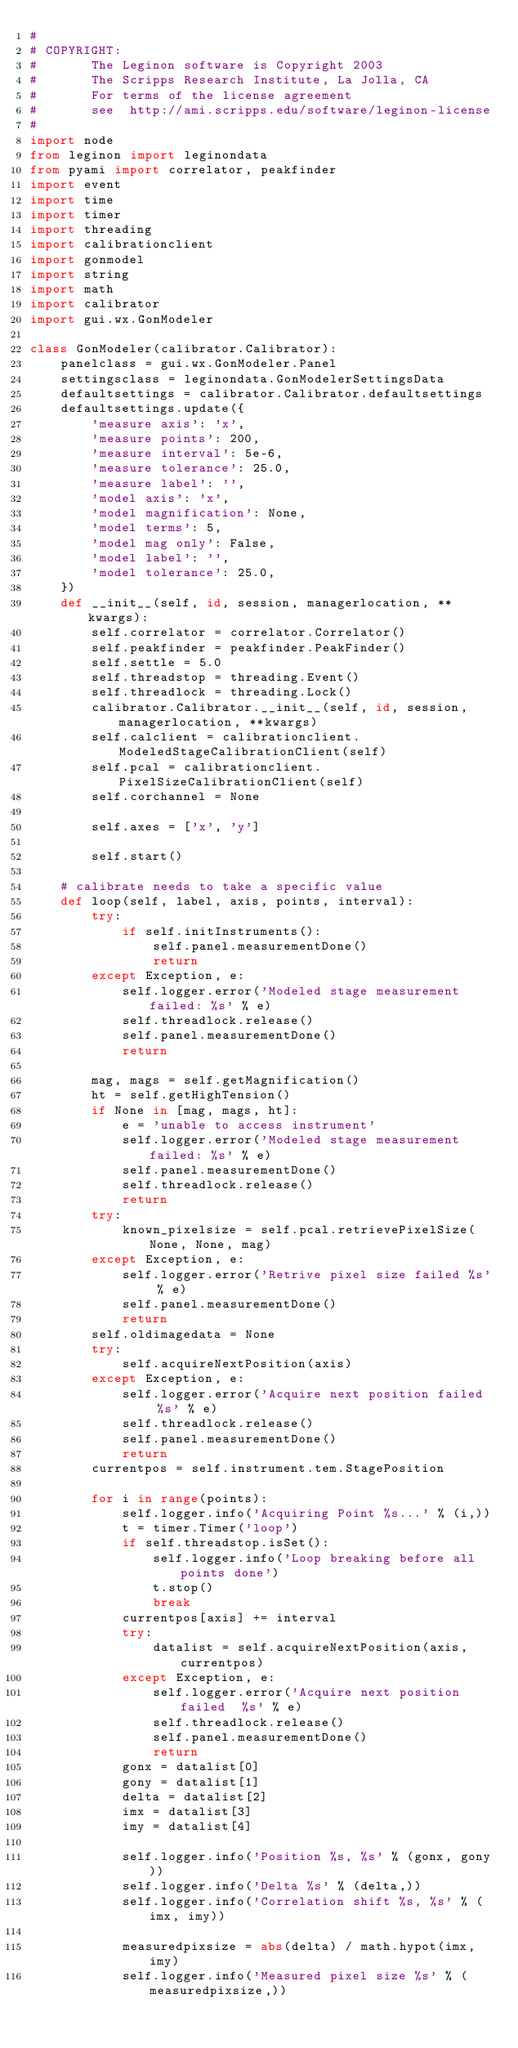Convert code to text. <code><loc_0><loc_0><loc_500><loc_500><_Python_>#
# COPYRIGHT:
#       The Leginon software is Copyright 2003
#       The Scripps Research Institute, La Jolla, CA
#       For terms of the license agreement
#       see  http://ami.scripps.edu/software/leginon-license
#
import node
from leginon import leginondata
from pyami import correlator, peakfinder
import event
import time
import timer
import threading
import calibrationclient
import gonmodel
import string
import math
import calibrator
import gui.wx.GonModeler

class GonModeler(calibrator.Calibrator):
	panelclass = gui.wx.GonModeler.Panel
	settingsclass = leginondata.GonModelerSettingsData
	defaultsettings = calibrator.Calibrator.defaultsettings
	defaultsettings.update({
		'measure axis': 'x',
		'measure points': 200,
		'measure interval': 5e-6,
		'measure tolerance': 25.0,
		'measure label': '',
		'model axis': 'x',
		'model magnification': None,
		'model terms': 5,
		'model mag only': False,
		'model label': '',
		'model tolerance': 25.0,
	})
	def __init__(self, id, session, managerlocation, **kwargs):
		self.correlator = correlator.Correlator()
		self.peakfinder = peakfinder.PeakFinder()
		self.settle = 5.0
		self.threadstop = threading.Event()
		self.threadlock = threading.Lock()
		calibrator.Calibrator.__init__(self, id, session, managerlocation, **kwargs)
		self.calclient = calibrationclient.ModeledStageCalibrationClient(self)
		self.pcal = calibrationclient.PixelSizeCalibrationClient(self)
		self.corchannel = None

		self.axes = ['x', 'y']

		self.start()

	# calibrate needs to take a specific value
	def loop(self, label, axis, points, interval):
		try:
			if self.initInstruments():
				self.panel.measurementDone()
				return
		except Exception, e:
			self.logger.error('Modeled stage measurement failed: %s' % e)
			self.threadlock.release()
			self.panel.measurementDone()
			return

		mag, mags = self.getMagnification()
		ht = self.getHighTension()
		if None in [mag, mags, ht]:
			e = 'unable to access instrument'
			self.logger.error('Modeled stage measurement failed: %s' % e)
			self.panel.measurementDone()
			self.threadlock.release()
			return
		try:
			known_pixelsize = self.pcal.retrievePixelSize(None, None, mag)
		except Exception, e:
			self.logger.error('Retrive pixel size failed %s' % e)
			self.panel.measurementDone()
			return
		self.oldimagedata = None
		try:
			self.acquireNextPosition(axis)
		except Exception, e:
			self.logger.error('Acquire next position failed  %s' % e)
			self.threadlock.release()
			self.panel.measurementDone()
			return
		currentpos = self.instrument.tem.StagePosition

		for i in range(points):
			self.logger.info('Acquiring Point %s...' % (i,))
			t = timer.Timer('loop')
			if self.threadstop.isSet():
				self.logger.info('Loop breaking before all points done')
				t.stop()
				break
			currentpos[axis] += interval
			try:
				datalist = self.acquireNextPosition(axis, currentpos)
			except Exception, e:
				self.logger.error('Acquire next position failed  %s' % e)
				self.threadlock.release()
				self.panel.measurementDone()
				return
			gonx = datalist[0]
			gony = datalist[1]
			delta = datalist[2]
			imx = datalist[3]
			imy = datalist[4]

			self.logger.info('Position %s, %s' % (gonx, gony))
			self.logger.info('Delta %s' % (delta,))
			self.logger.info('Correlation shift %s, %s' % (imx, imy))

			measuredpixsize = abs(delta) / math.hypot(imx,imy)
			self.logger.info('Measured pixel size %s' % (measuredpixsize,))</code> 